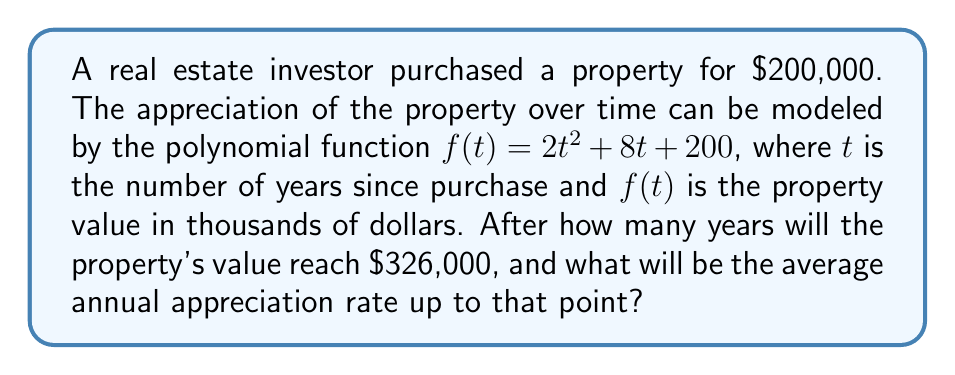Teach me how to tackle this problem. To solve this problem, we need to follow these steps:

1) First, we need to find when the property value reaches $326,000. This means solving the equation:

   $f(t) = 326$

   $2t^2 + 8t + 200 = 326$

2) Rearrange the equation:

   $2t^2 + 8t - 126 = 0$

3) This is a quadratic equation. We can solve it by factoring:

   $2(t^2 + 4t - 63) = 0$
   $2(t + 9)(t - 5) = 0$

4) Solving this, we get $t = 5$ or $t = -9$. Since time can't be negative in this context, $t = 5$ years.

5) Now, to calculate the average annual appreciation rate, we use the compound annual growth rate (CAGR) formula:

   $CAGR = (\frac{Ending Value}{Beginning Value})^{\frac{1}{n}} - 1$

   Where $n$ is the number of years.

6) Plugging in our values:

   $CAGR = (\frac{326,000}{200,000})^{\frac{1}{5}} - 1$

7) Calculating:

   $CAGR = (1.63)^{0.2} - 1 = 1.1022 - 1 = 0.1022$

8) Convert to percentage:

   $0.1022 * 100 = 10.22\%$

Therefore, the property will reach $326,000 after 5 years, with an average annual appreciation rate of 10.22%.
Answer: The property will reach $326,000 after 5 years, with an average annual appreciation rate of 10.22%. 